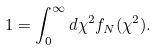Convert formula to latex. <formula><loc_0><loc_0><loc_500><loc_500>1 = \int _ { 0 } ^ { \infty } d \chi ^ { 2 } f _ { N } ( \chi ^ { 2 } ) .</formula> 